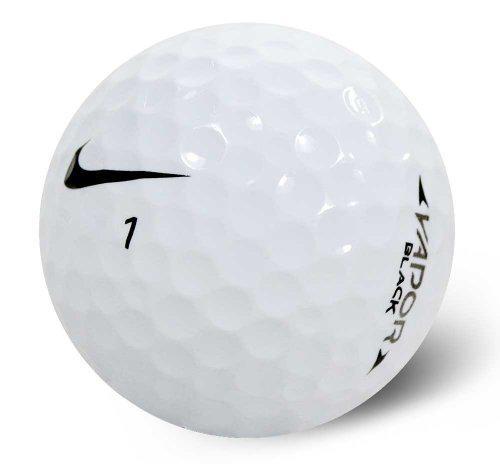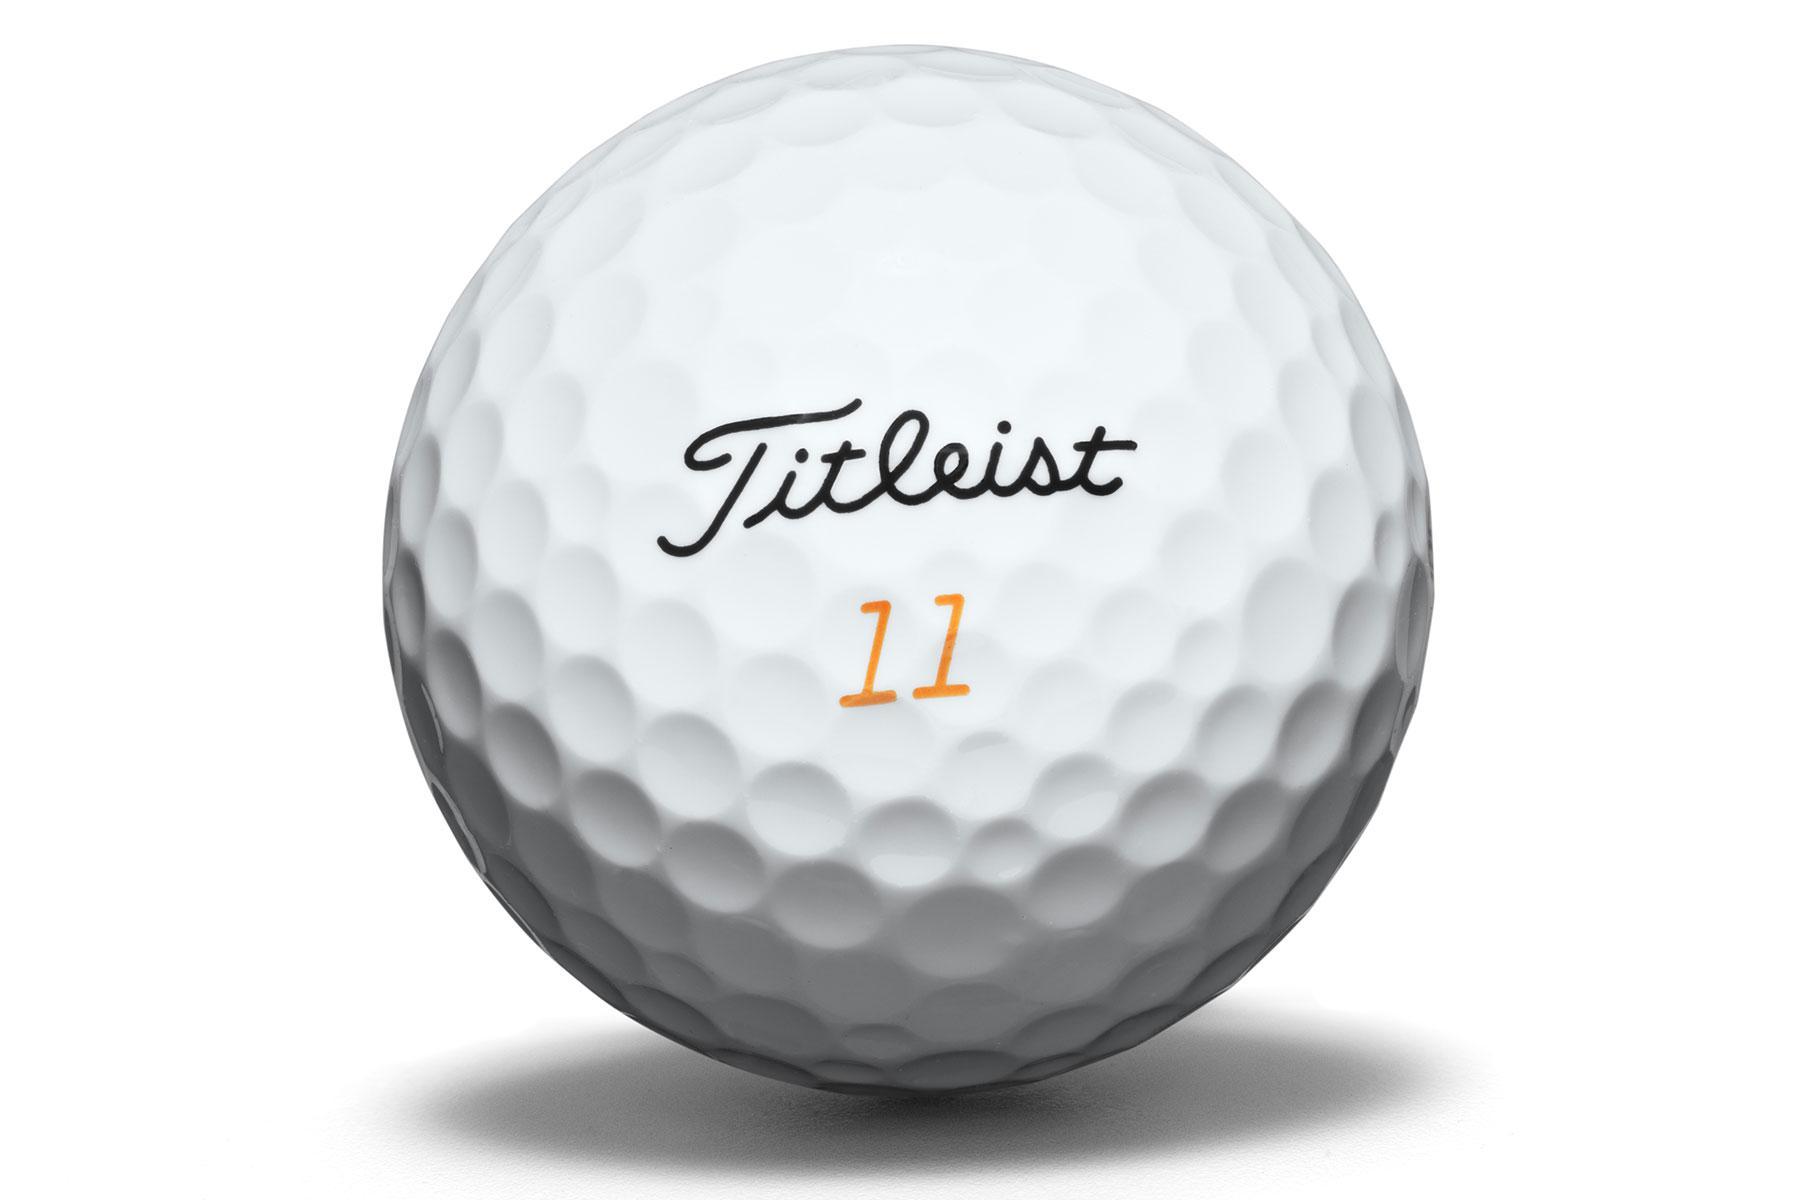The first image is the image on the left, the second image is the image on the right. Considering the images on both sides, is "The number 1 is on exactly one of the balls." valid? Answer yes or no. Yes. 